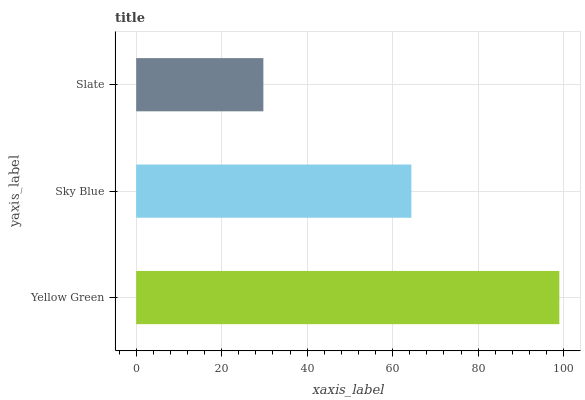Is Slate the minimum?
Answer yes or no. Yes. Is Yellow Green the maximum?
Answer yes or no. Yes. Is Sky Blue the minimum?
Answer yes or no. No. Is Sky Blue the maximum?
Answer yes or no. No. Is Yellow Green greater than Sky Blue?
Answer yes or no. Yes. Is Sky Blue less than Yellow Green?
Answer yes or no. Yes. Is Sky Blue greater than Yellow Green?
Answer yes or no. No. Is Yellow Green less than Sky Blue?
Answer yes or no. No. Is Sky Blue the high median?
Answer yes or no. Yes. Is Sky Blue the low median?
Answer yes or no. Yes. Is Yellow Green the high median?
Answer yes or no. No. Is Slate the low median?
Answer yes or no. No. 